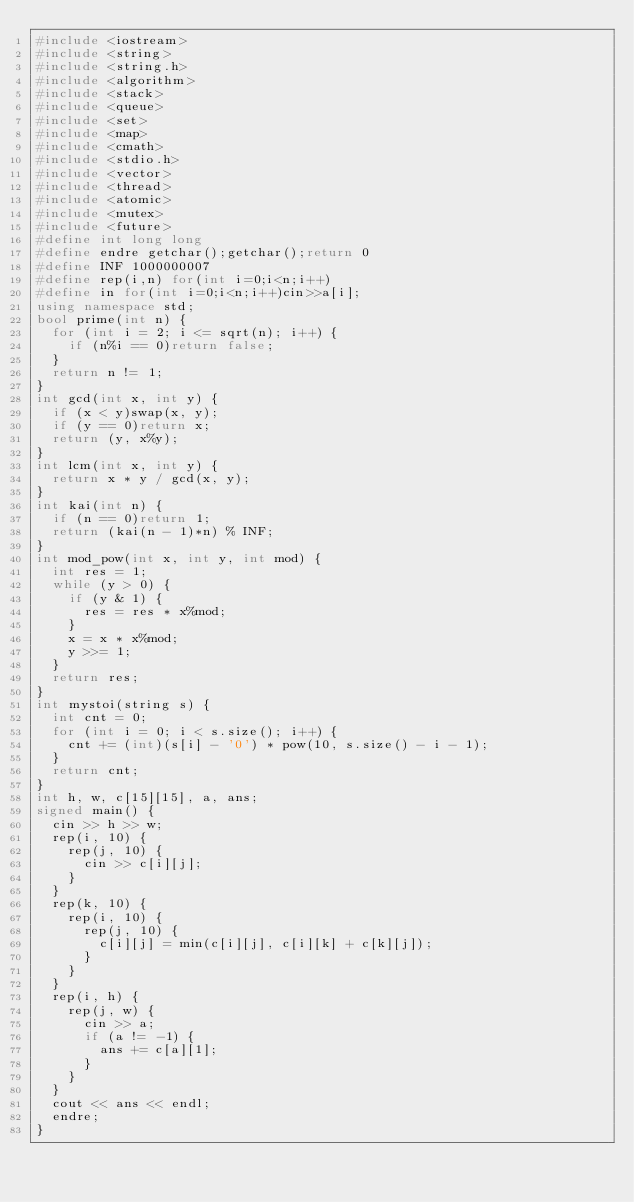Convert code to text. <code><loc_0><loc_0><loc_500><loc_500><_C++_>#include <iostream>
#include <string>
#include <string.h>
#include <algorithm>
#include <stack>
#include <queue>
#include <set>
#include <map>
#include <cmath>
#include <stdio.h>
#include <vector>
#include <thread>
#include <atomic>
#include <mutex>
#include <future>
#define int long long
#define endre getchar();getchar();return 0
#define INF 1000000007
#define rep(i,n) for(int i=0;i<n;i++)
#define in for(int i=0;i<n;i++)cin>>a[i];
using namespace std;
bool prime(int n) {
	for (int i = 2; i <= sqrt(n); i++) {
		if (n%i == 0)return false;
	}
	return n != 1;
}
int gcd(int x, int y) {
	if (x < y)swap(x, y);
	if (y == 0)return x;
	return (y, x%y);
}
int lcm(int x, int y) {
	return x * y / gcd(x, y);
}
int kai(int n) {
	if (n == 0)return 1;
	return (kai(n - 1)*n) % INF;
}
int mod_pow(int x, int y, int mod) {
	int res = 1;
	while (y > 0) {
		if (y & 1) {
			res = res * x%mod;
		}
		x = x * x%mod;
		y >>= 1;
	}
	return res;
}
int mystoi(string s) {
	int cnt = 0;
	for (int i = 0; i < s.size(); i++) {
		cnt += (int)(s[i] - '0') * pow(10, s.size() - i - 1);
	}
	return cnt;
}
int h, w, c[15][15], a, ans;
signed main() {
	cin >> h >> w;
	rep(i, 10) {
		rep(j, 10) {
			cin >> c[i][j];
		}
	}
	rep(k, 10) {
		rep(i, 10) {
			rep(j, 10) {
				c[i][j] = min(c[i][j], c[i][k] + c[k][j]);
			}
		}
	}
	rep(i, h) {
		rep(j, w) {
			cin >> a;
			if (a != -1) {
				ans += c[a][1];
			}
		}
	}
	cout << ans << endl;
	endre;
}</code> 